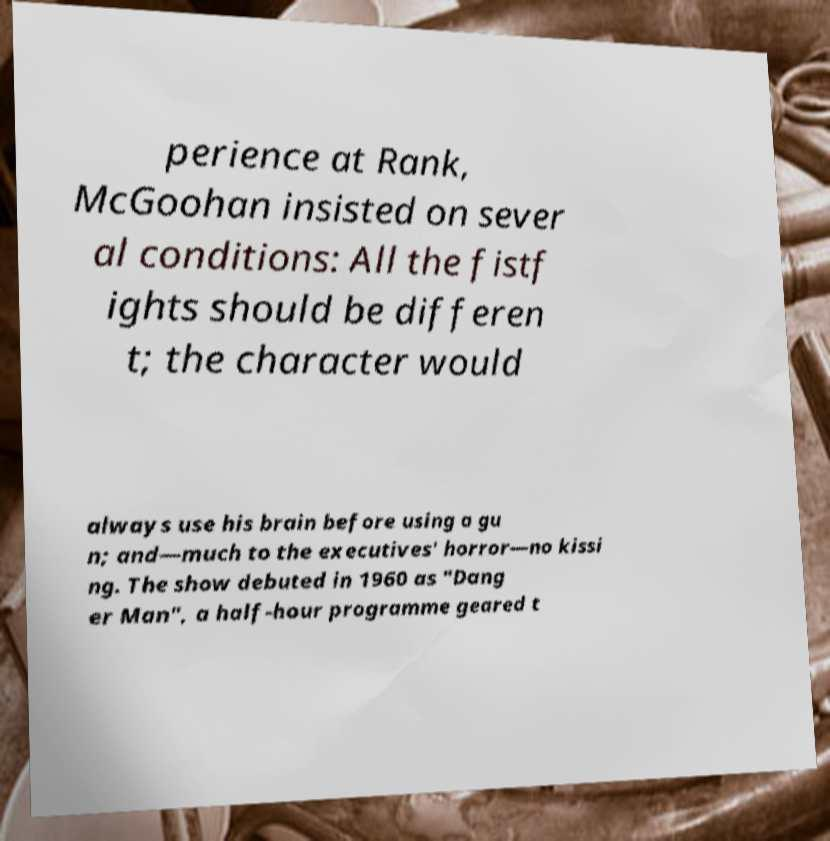Can you read and provide the text displayed in the image?This photo seems to have some interesting text. Can you extract and type it out for me? perience at Rank, McGoohan insisted on sever al conditions: All the fistf ights should be differen t; the character would always use his brain before using a gu n; and—much to the executives' horror—no kissi ng. The show debuted in 1960 as "Dang er Man", a half-hour programme geared t 